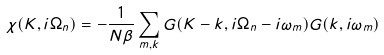Convert formula to latex. <formula><loc_0><loc_0><loc_500><loc_500>\chi ( { K } , i \Omega _ { n } ) = - \frac { 1 } { N \beta } \sum _ { m , { k } } G ( { K } - { k } , i \Omega _ { n } - i \omega _ { m } ) G ( { k } , i \omega _ { m } )</formula> 